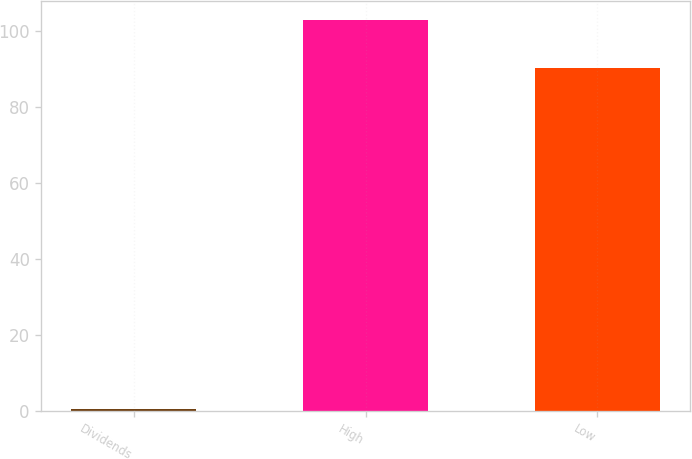Convert chart to OTSL. <chart><loc_0><loc_0><loc_500><loc_500><bar_chart><fcel>Dividends<fcel>High<fcel>Low<nl><fcel>0.46<fcel>102.96<fcel>90.36<nl></chart> 